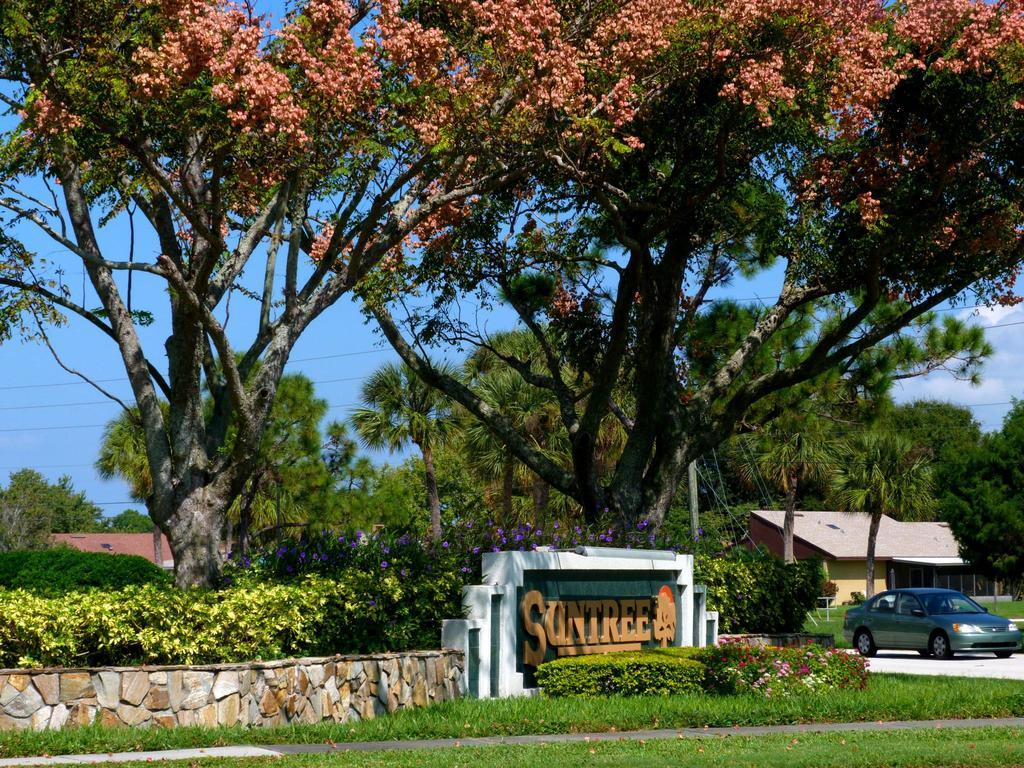What type of vegetation is present in the image? There is grass in the image. What can be seen on the right side of the image? There is a car and a house on the right side of the image. What is written on a surface in the image? There is text written on a wall in the image. What is visible in the background of the image? There are trees and the sky visible in the background of the image. What type of cushion is used for the treatment of the list in the image? There is no cushion, treatment, or list present in the image. 